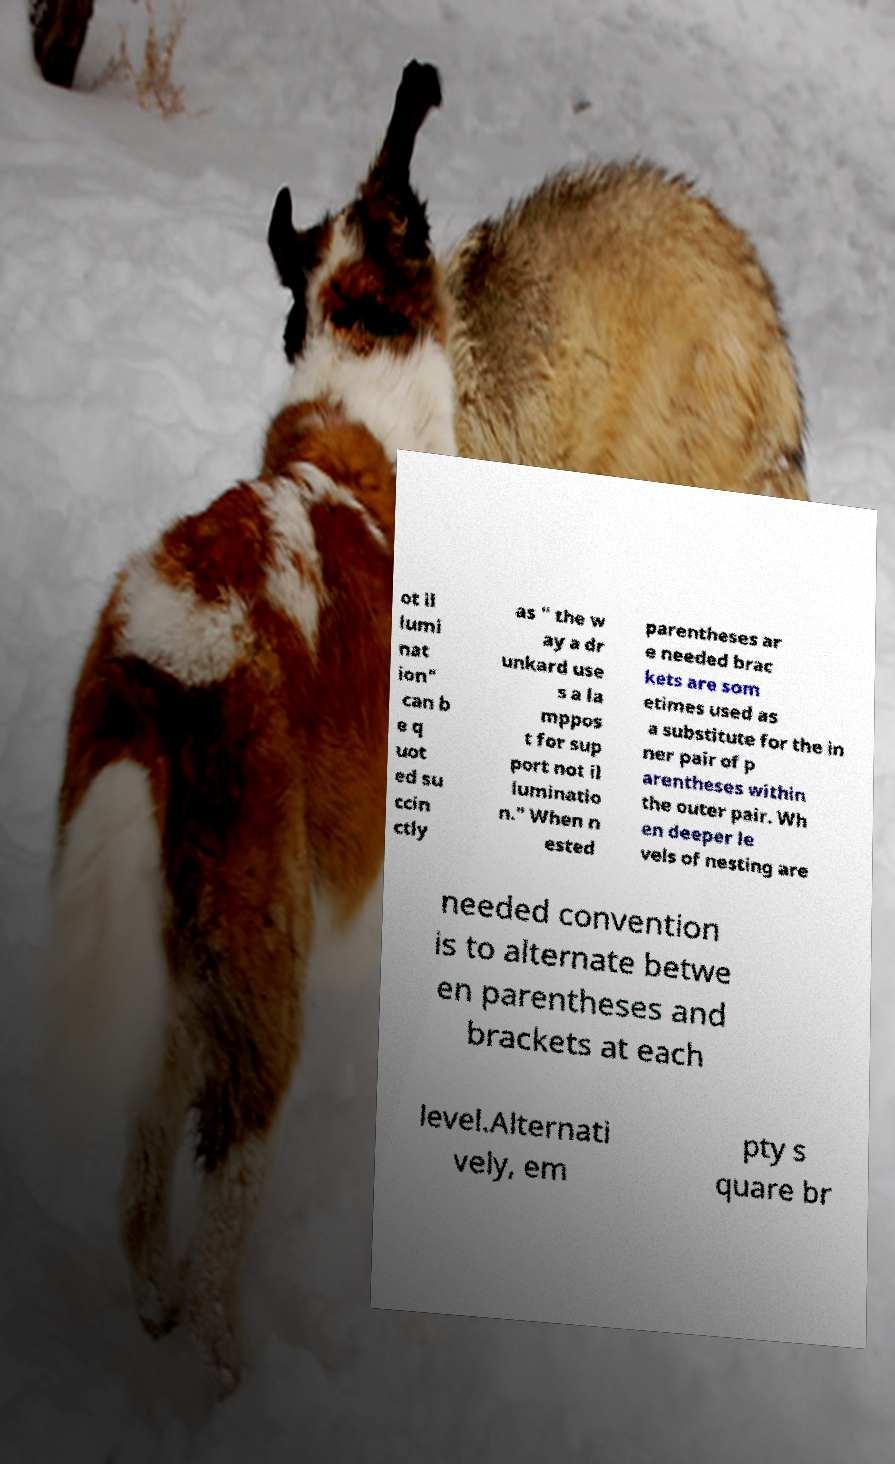Can you read and provide the text displayed in the image?This photo seems to have some interesting text. Can you extract and type it out for me? ot il lumi nat ion" can b e q uot ed su ccin ctly as " the w ay a dr unkard use s a la mppos t for sup port not il luminatio n." When n ested parentheses ar e needed brac kets are som etimes used as a substitute for the in ner pair of p arentheses within the outer pair. Wh en deeper le vels of nesting are needed convention is to alternate betwe en parentheses and brackets at each level.Alternati vely, em pty s quare br 